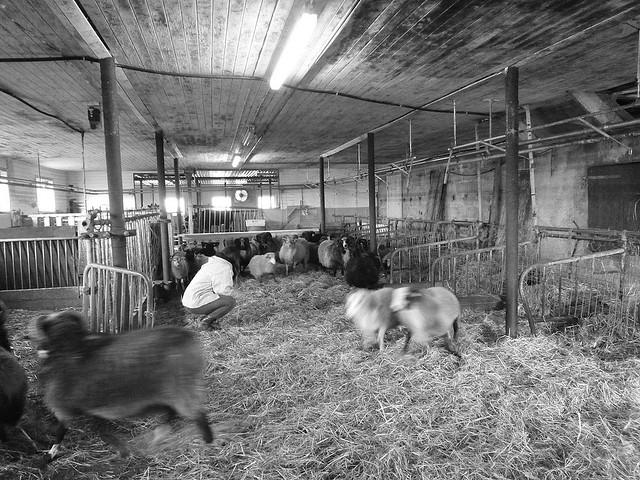Does this look like a barn?
Be succinct. Yes. What are the animals standing on?
Be succinct. Hay. Are some of the animals blurry?
Keep it brief. Yes. 